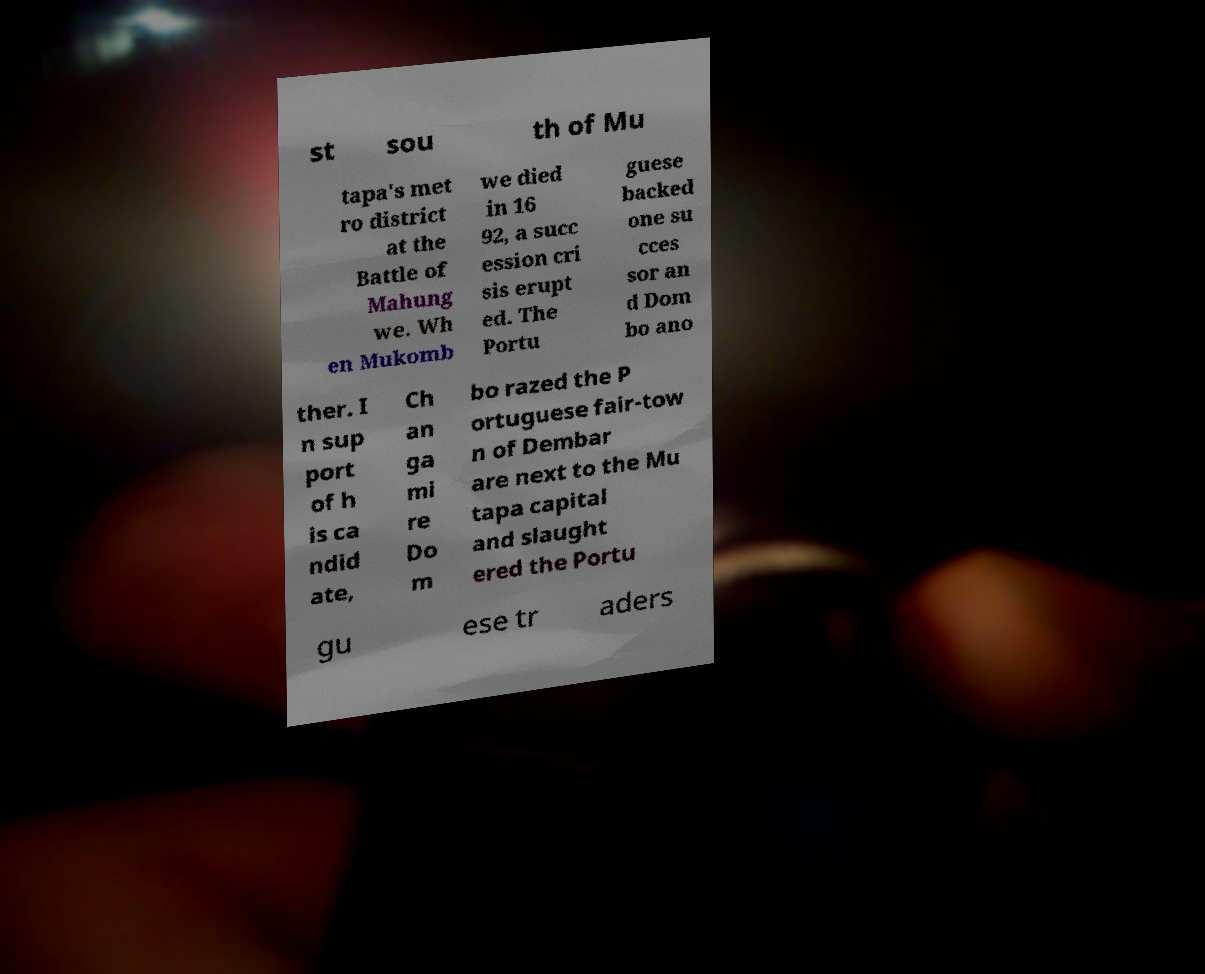Please read and relay the text visible in this image. What does it say? st sou th of Mu tapa's met ro district at the Battle of Mahung we. Wh en Mukomb we died in 16 92, a succ ession cri sis erupt ed. The Portu guese backed one su cces sor an d Dom bo ano ther. I n sup port of h is ca ndid ate, Ch an ga mi re Do m bo razed the P ortuguese fair-tow n of Dembar are next to the Mu tapa capital and slaught ered the Portu gu ese tr aders 